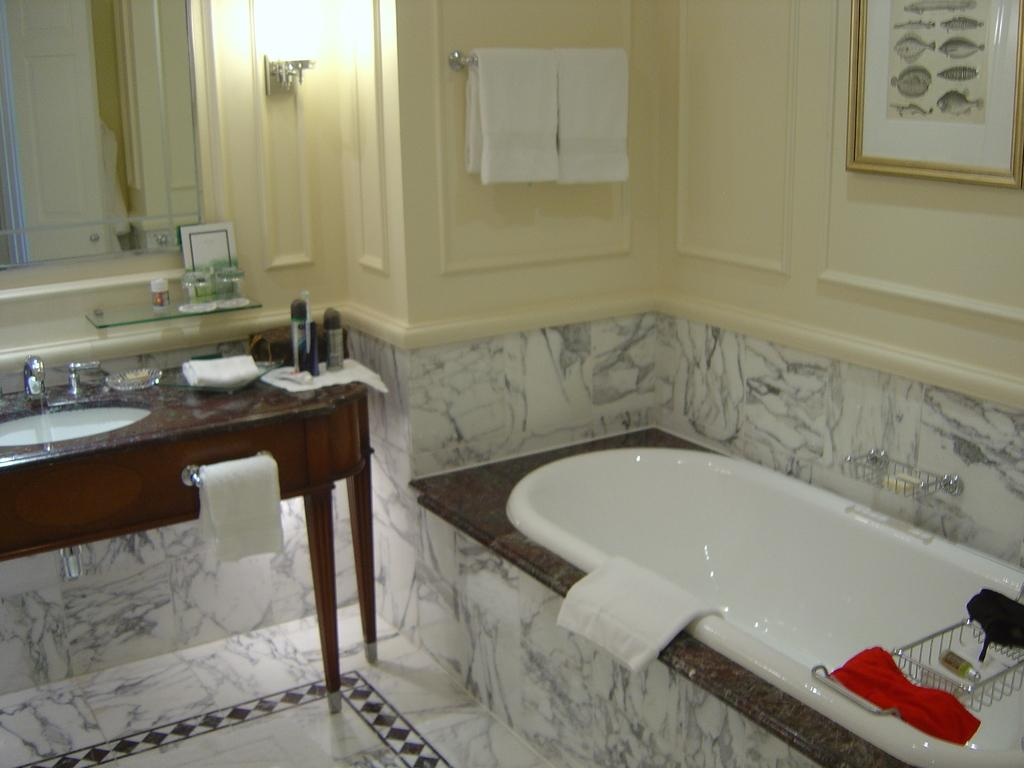What is the main object in the image? There is a bathing tub in the image. What other furniture or objects can be seen in the image? There is a table in the image. What is on the table? There is a dish wash bar on the table, and there are objects on the table. What can be used for personal grooming in the image? There is a mirror in the image. What is hanging on the wall? There is a photo frame on the wall. What type of bone is visible in the image? There is no bone present in the image. How many stitches are visible on the photo frame in the image? There is no mention of stitches or any stitched objects in the image. 